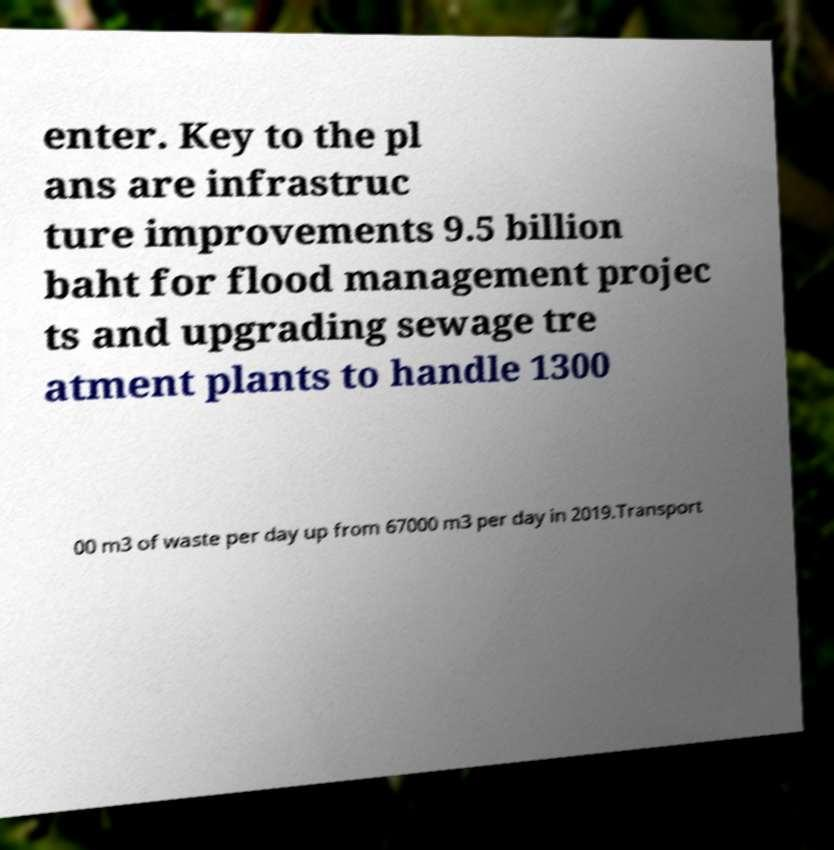For documentation purposes, I need the text within this image transcribed. Could you provide that? enter. Key to the pl ans are infrastruc ture improvements 9.5 billion baht for flood management projec ts and upgrading sewage tre atment plants to handle 1300 00 m3 of waste per day up from 67000 m3 per day in 2019.Transport 